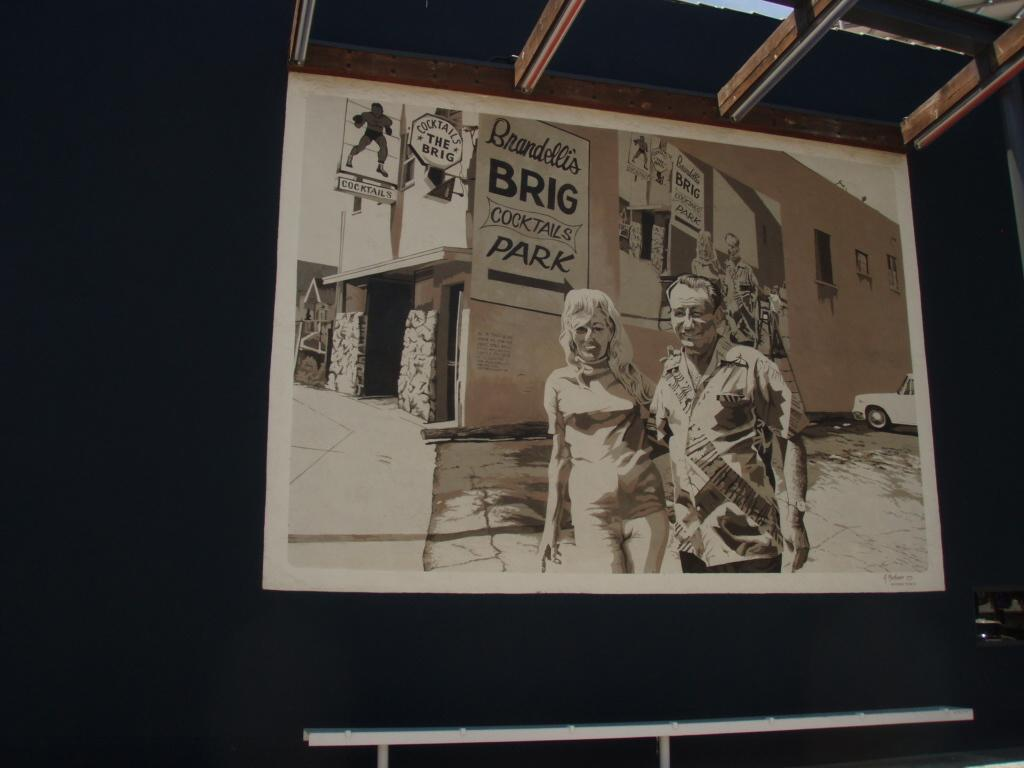Provide a one-sentence caption for the provided image. The arrow is pointing to where people need to park. 